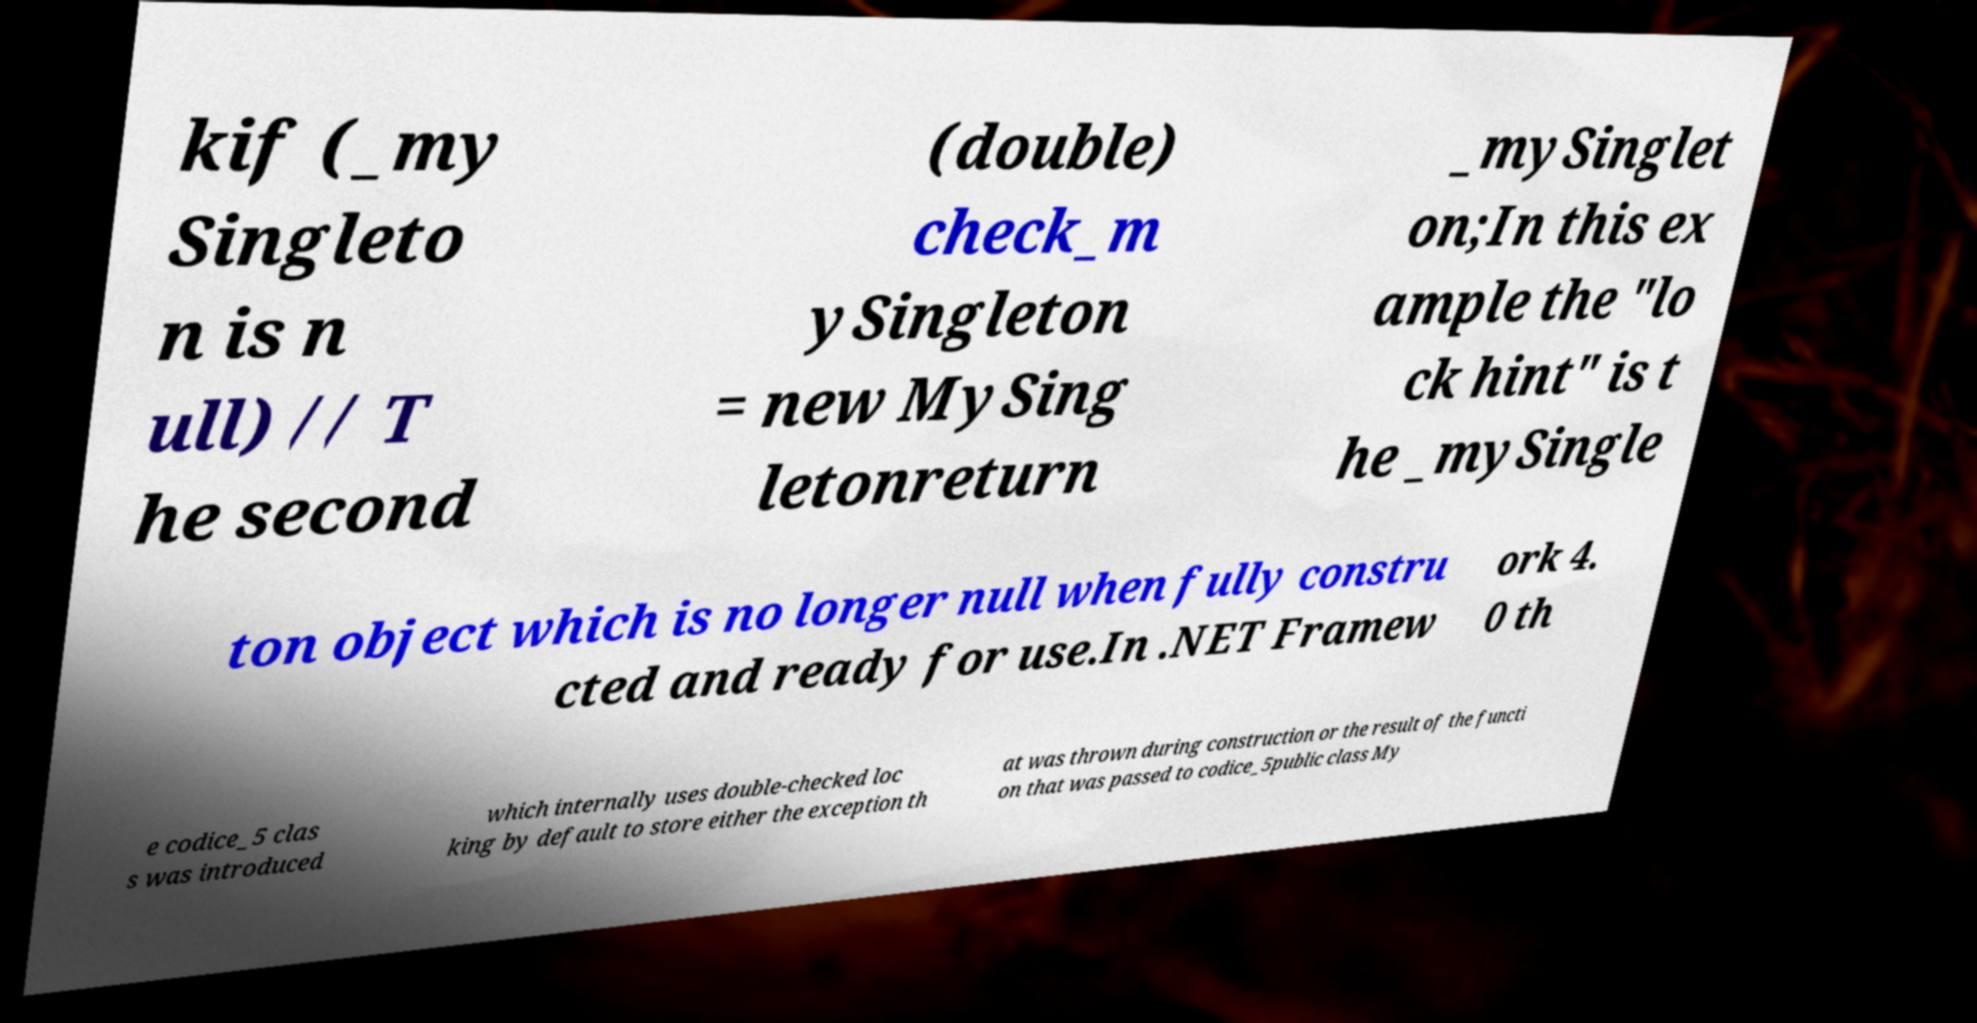Could you assist in decoding the text presented in this image and type it out clearly? kif (_my Singleto n is n ull) // T he second (double) check_m ySingleton = new MySing letonreturn _mySinglet on;In this ex ample the "lo ck hint" is t he _mySingle ton object which is no longer null when fully constru cted and ready for use.In .NET Framew ork 4. 0 th e codice_5 clas s was introduced which internally uses double-checked loc king by default to store either the exception th at was thrown during construction or the result of the functi on that was passed to codice_5public class My 